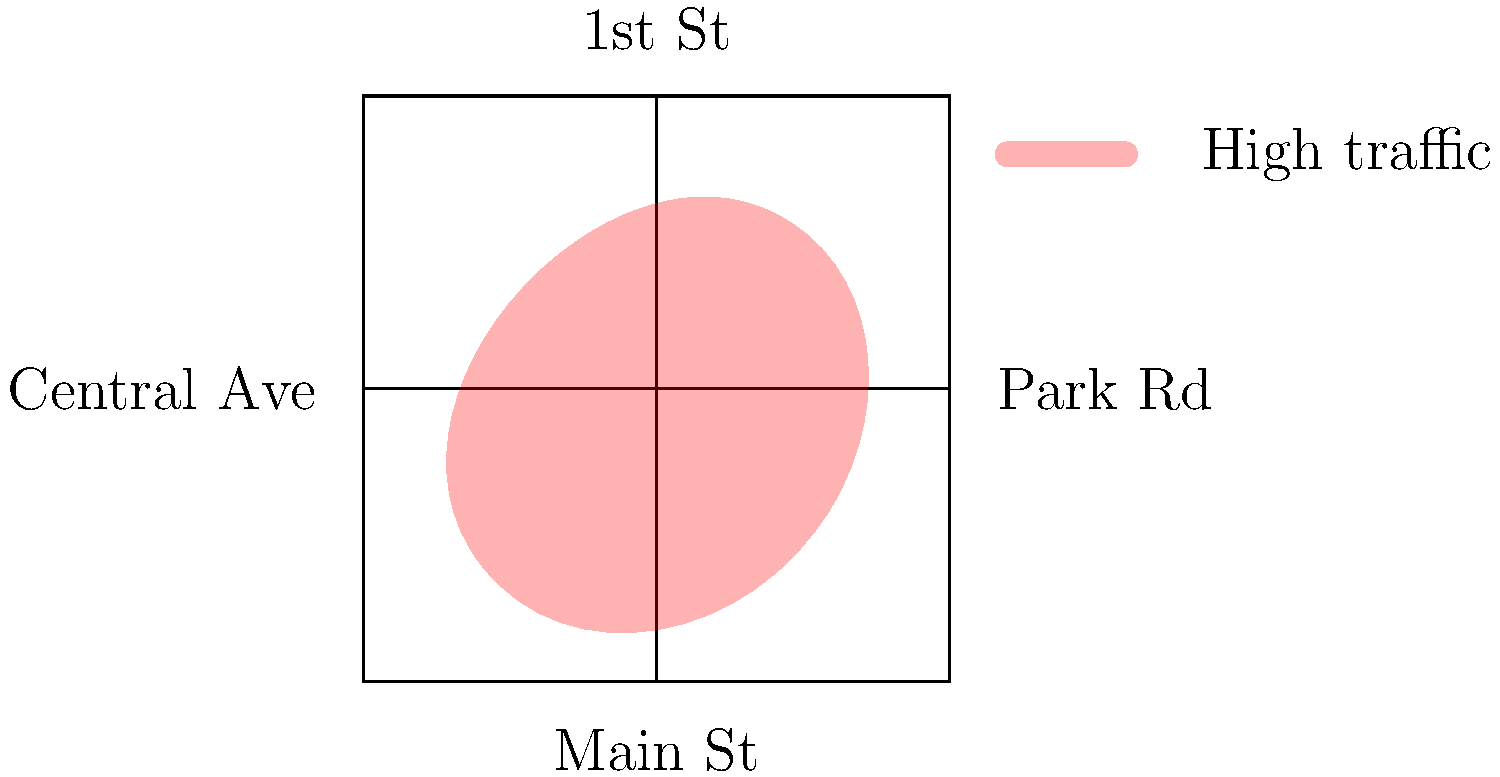Based on the heat map overlay of Warman's street layout, which intersection appears to be the most congested point in the city? To determine the most congested intersection in Warman based on the heat map:

1. Observe the red overlay on the street map, which indicates areas of high traffic.
2. The darker or more intense the red color, the higher the traffic congestion.
3. Identify the intersections on the map:
   a. Main St and Central Ave (center)
   b. Main St and 1st St (top)
   c. Main St and Park Rd (right)
   d. Central Ave and 1st St (left)
4. Analyze the heat map intensity at each intersection.
5. The intersection of Main St and Central Ave (center) shows the highest concentration of red, indicating the most congestion.
6. This central location likely experiences the most traffic due to its position connecting all four major streets.

Therefore, the intersection of Main St and Central Ave appears to be the most congested point in Warman.
Answer: Main St and Central Ave intersection 